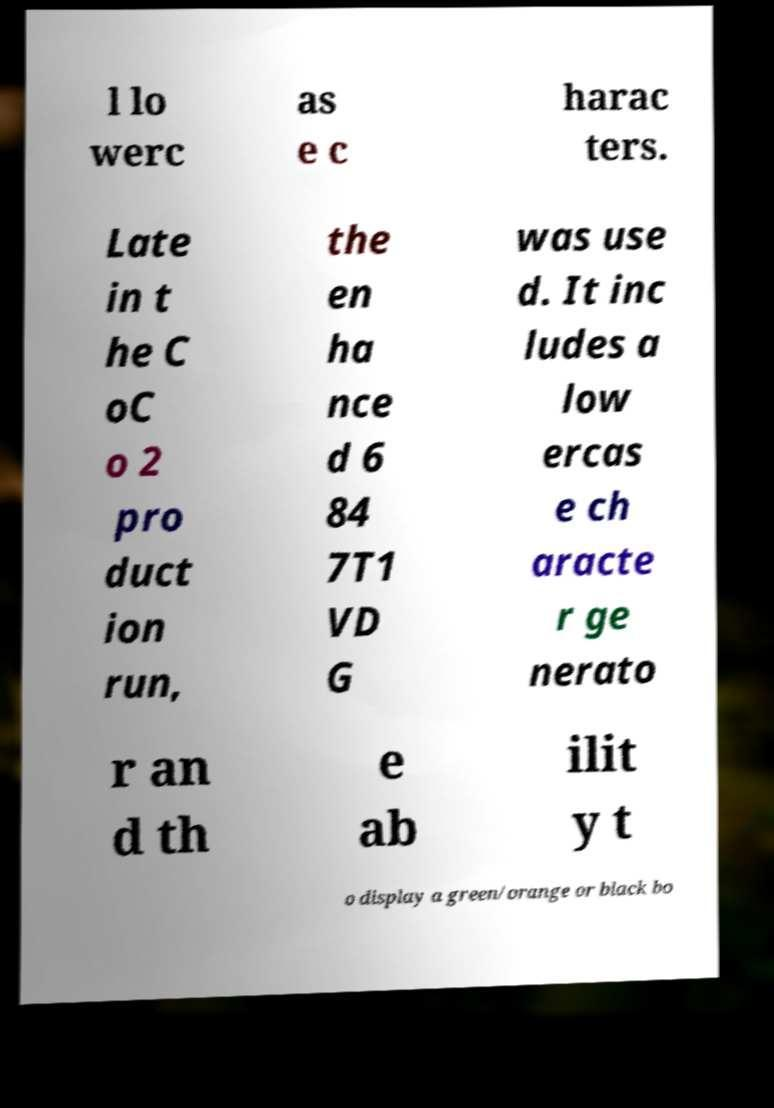I need the written content from this picture converted into text. Can you do that? l lo werc as e c harac ters. Late in t he C oC o 2 pro duct ion run, the en ha nce d 6 84 7T1 VD G was use d. It inc ludes a low ercas e ch aracte r ge nerato r an d th e ab ilit y t o display a green/orange or black bo 